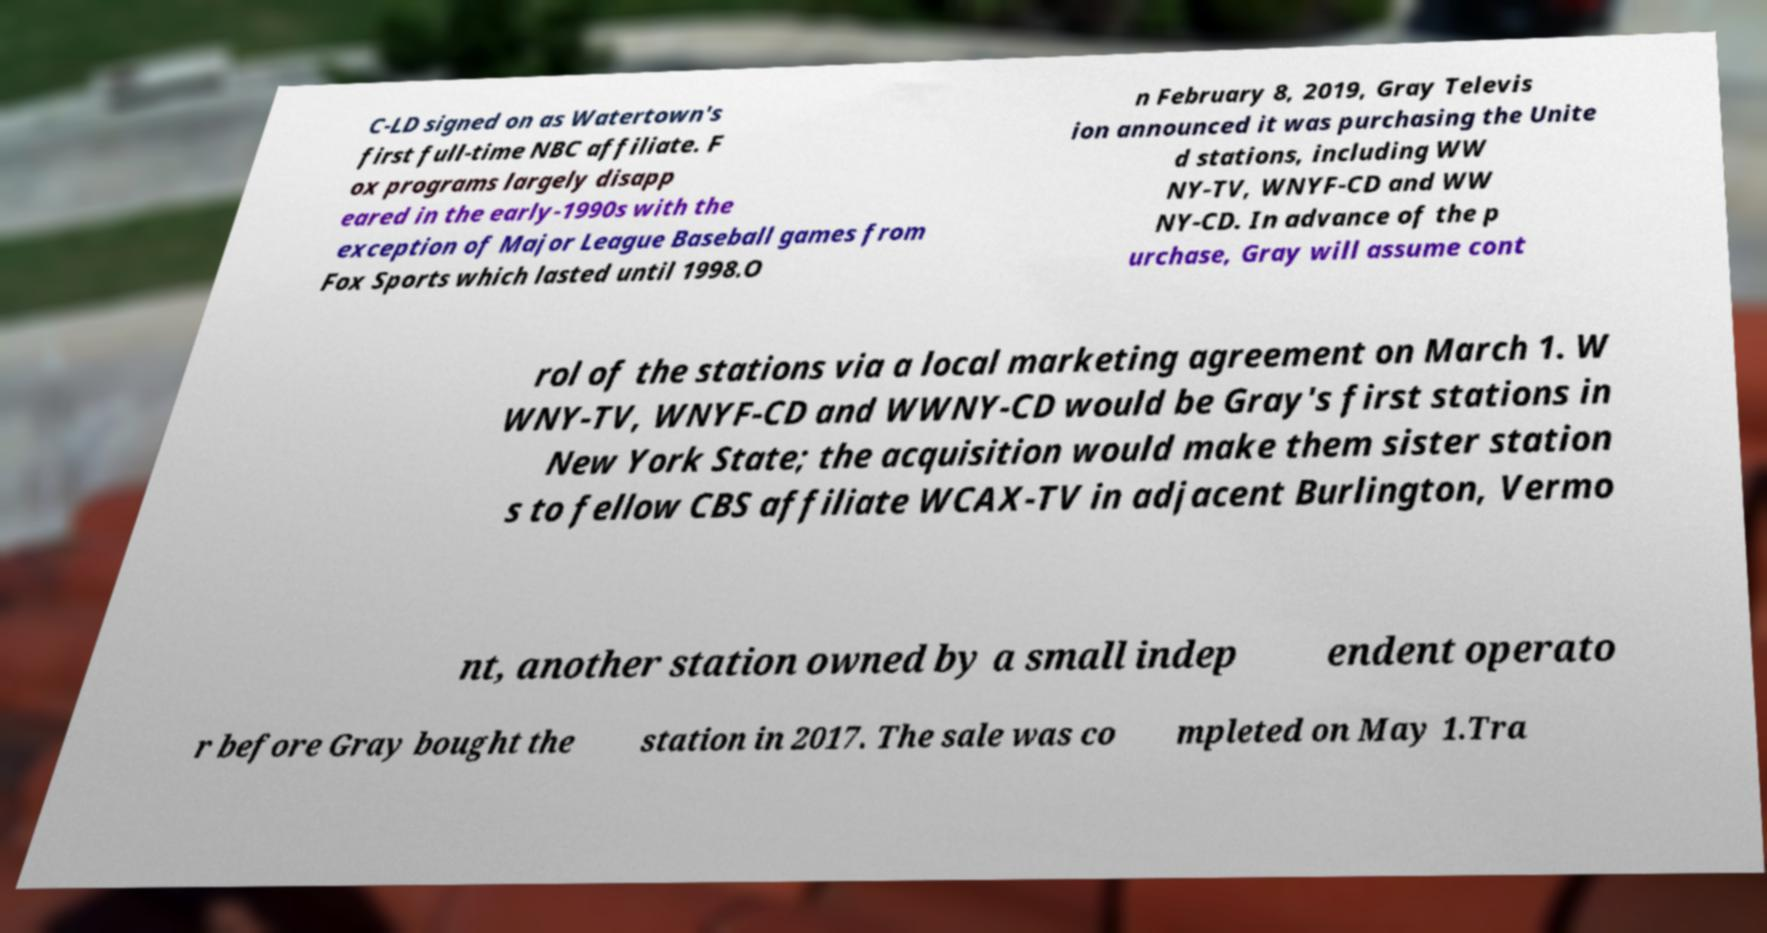Please read and relay the text visible in this image. What does it say? C-LD signed on as Watertown's first full-time NBC affiliate. F ox programs largely disapp eared in the early-1990s with the exception of Major League Baseball games from Fox Sports which lasted until 1998.O n February 8, 2019, Gray Televis ion announced it was purchasing the Unite d stations, including WW NY-TV, WNYF-CD and WW NY-CD. In advance of the p urchase, Gray will assume cont rol of the stations via a local marketing agreement on March 1. W WNY-TV, WNYF-CD and WWNY-CD would be Gray's first stations in New York State; the acquisition would make them sister station s to fellow CBS affiliate WCAX-TV in adjacent Burlington, Vermo nt, another station owned by a small indep endent operato r before Gray bought the station in 2017. The sale was co mpleted on May 1.Tra 